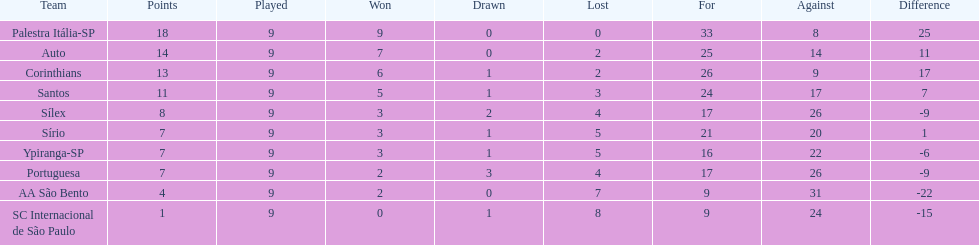Give me the full table as a dictionary. {'header': ['Team', 'Points', 'Played', 'Won', 'Drawn', 'Lost', 'For', 'Against', 'Difference'], 'rows': [['Palestra Itália-SP', '18', '9', '9', '0', '0', '33', '8', '25'], ['Auto', '14', '9', '7', '0', '2', '25', '14', '11'], ['Corinthians', '13', '9', '6', '1', '2', '26', '9', '17'], ['Santos', '11', '9', '5', '1', '3', '24', '17', '7'], ['Sílex', '8', '9', '3', '2', '4', '17', '26', '-9'], ['Sírio', '7', '9', '3', '1', '5', '21', '20', '1'], ['Ypiranga-SP', '7', '9', '3', '1', '5', '16', '22', '-6'], ['Portuguesa', '7', '9', '2', '3', '4', '17', '26', '-9'], ['AA São Bento', '4', '9', '2', '0', '7', '9', '31', '-22'], ['SC Internacional de São Paulo', '1', '9', '0', '1', '8', '9', '24', '-15']]} How many points did the brazilian football team auto get in 1926? 14. 